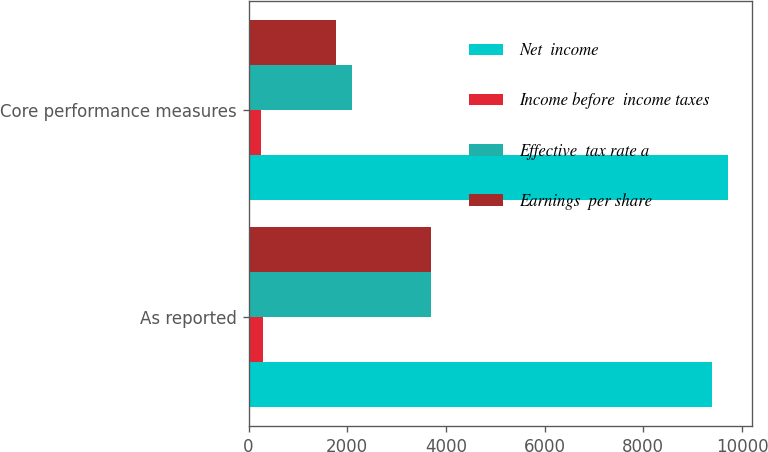Convert chart to OTSL. <chart><loc_0><loc_0><loc_500><loc_500><stacked_bar_chart><ecel><fcel>As reported<fcel>Core performance measures<nl><fcel>Net  income<fcel>9390<fcel>9710<nl><fcel>Income before  income taxes<fcel>284<fcel>250<nl><fcel>Effective  tax rate a<fcel>3692<fcel>2096<nl><fcel>Earnings  per share<fcel>3695<fcel>1774<nl></chart> 